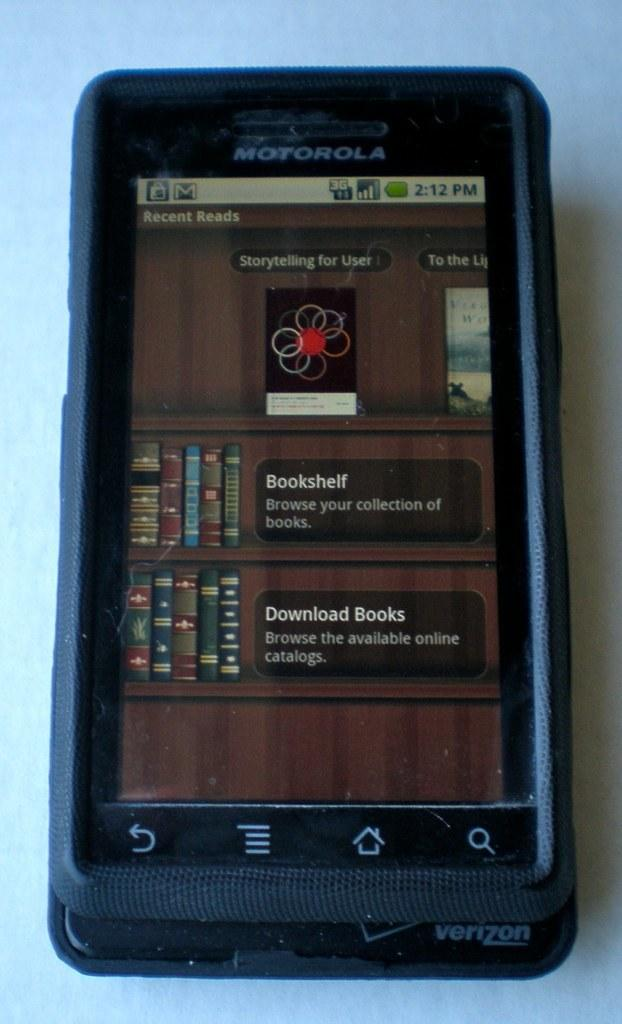<image>
Write a terse but informative summary of the picture. A Motorola smart phone displays an app where books can be downloaded. 